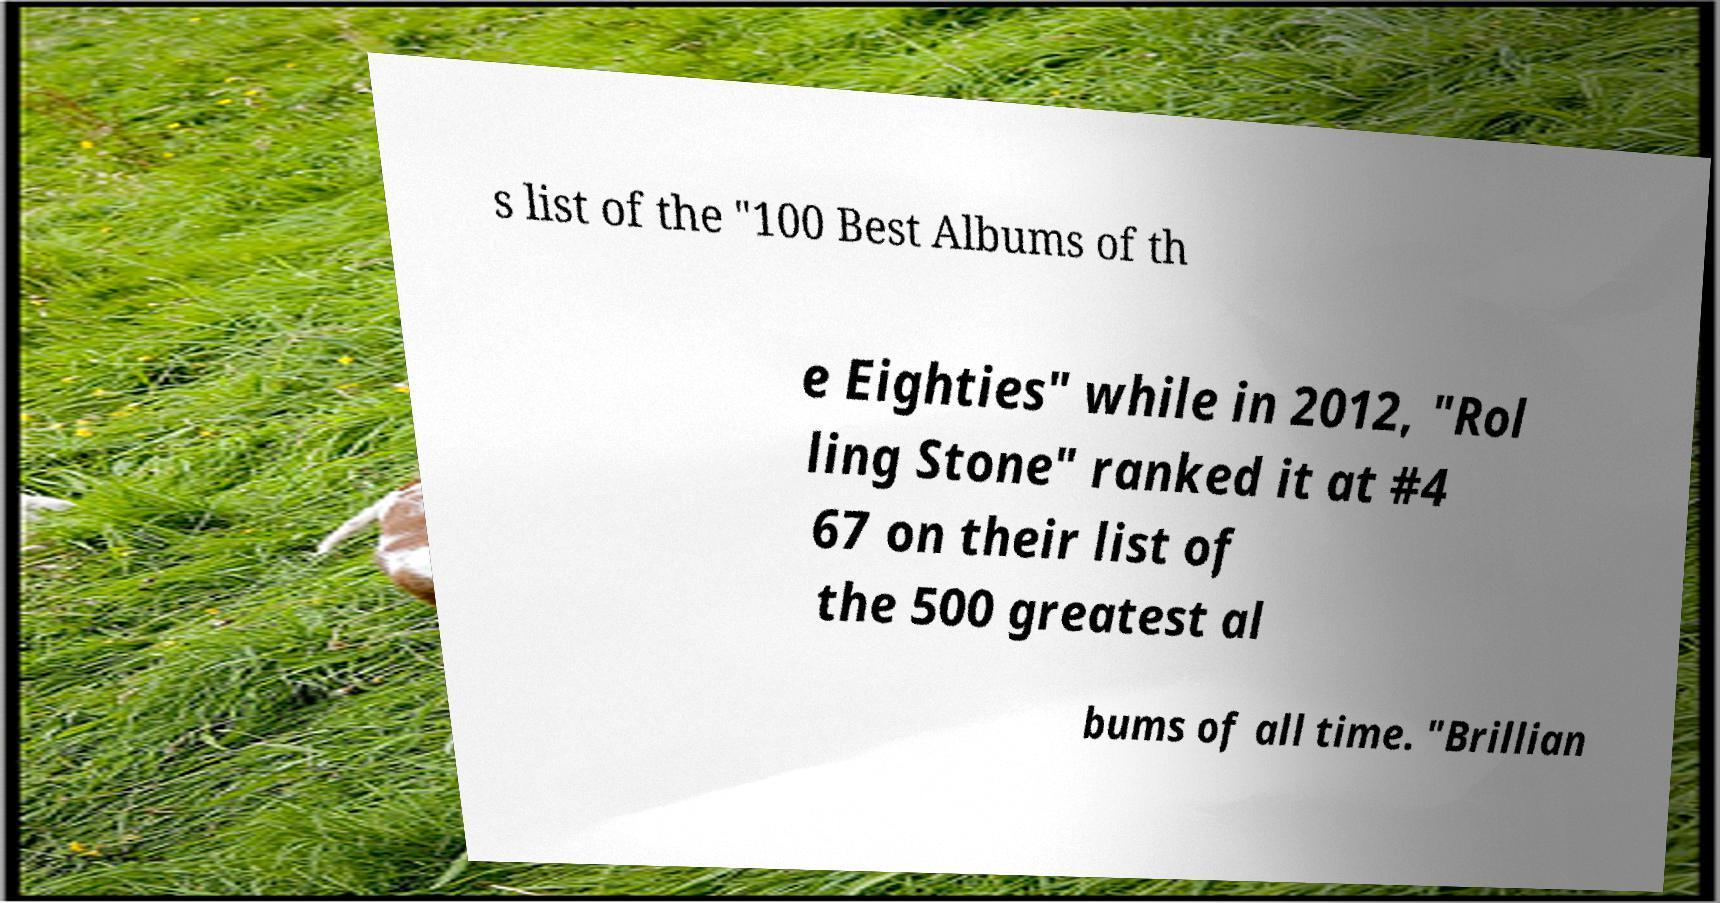I need the written content from this picture converted into text. Can you do that? s list of the "100 Best Albums of th e Eighties" while in 2012, "Rol ling Stone" ranked it at #4 67 on their list of the 500 greatest al bums of all time. "Brillian 